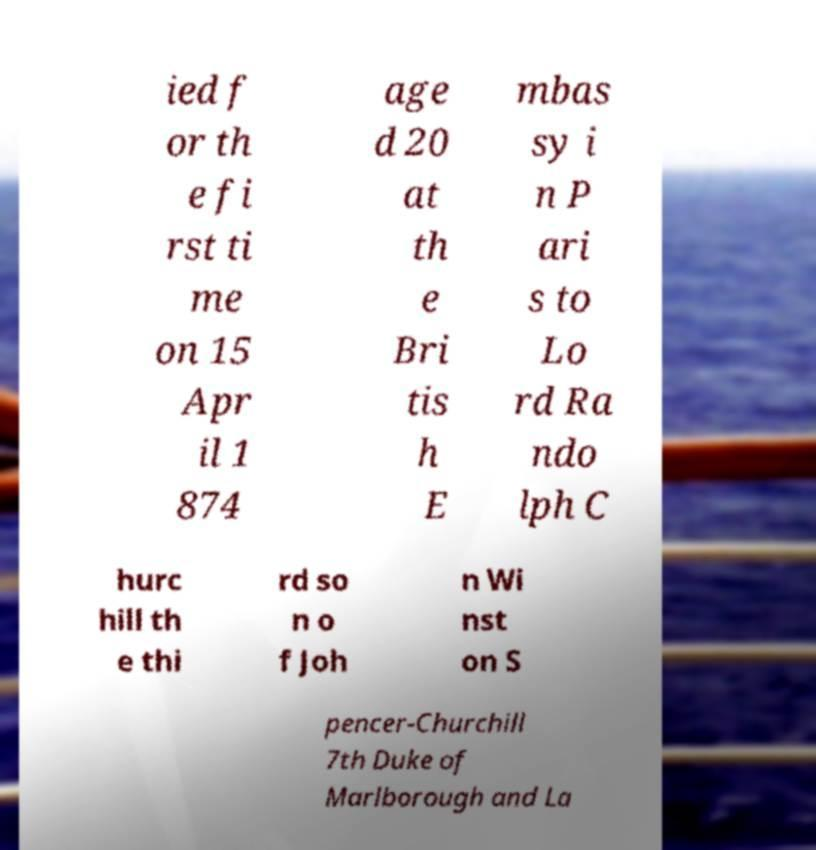Please identify and transcribe the text found in this image. ied f or th e fi rst ti me on 15 Apr il 1 874 age d 20 at th e Bri tis h E mbas sy i n P ari s to Lo rd Ra ndo lph C hurc hill th e thi rd so n o f Joh n Wi nst on S pencer-Churchill 7th Duke of Marlborough and La 